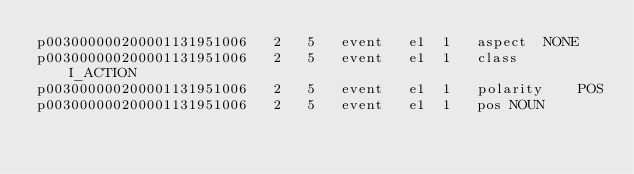<code> <loc_0><loc_0><loc_500><loc_500><_SQL_>p003000000200001131951006	2	5	event	e1	1	aspect	NONE
p003000000200001131951006	2	5	event	e1	1	class	I_ACTION
p003000000200001131951006	2	5	event	e1	1	polarity	POS
p003000000200001131951006	2	5	event	e1	1	pos	NOUN</code> 